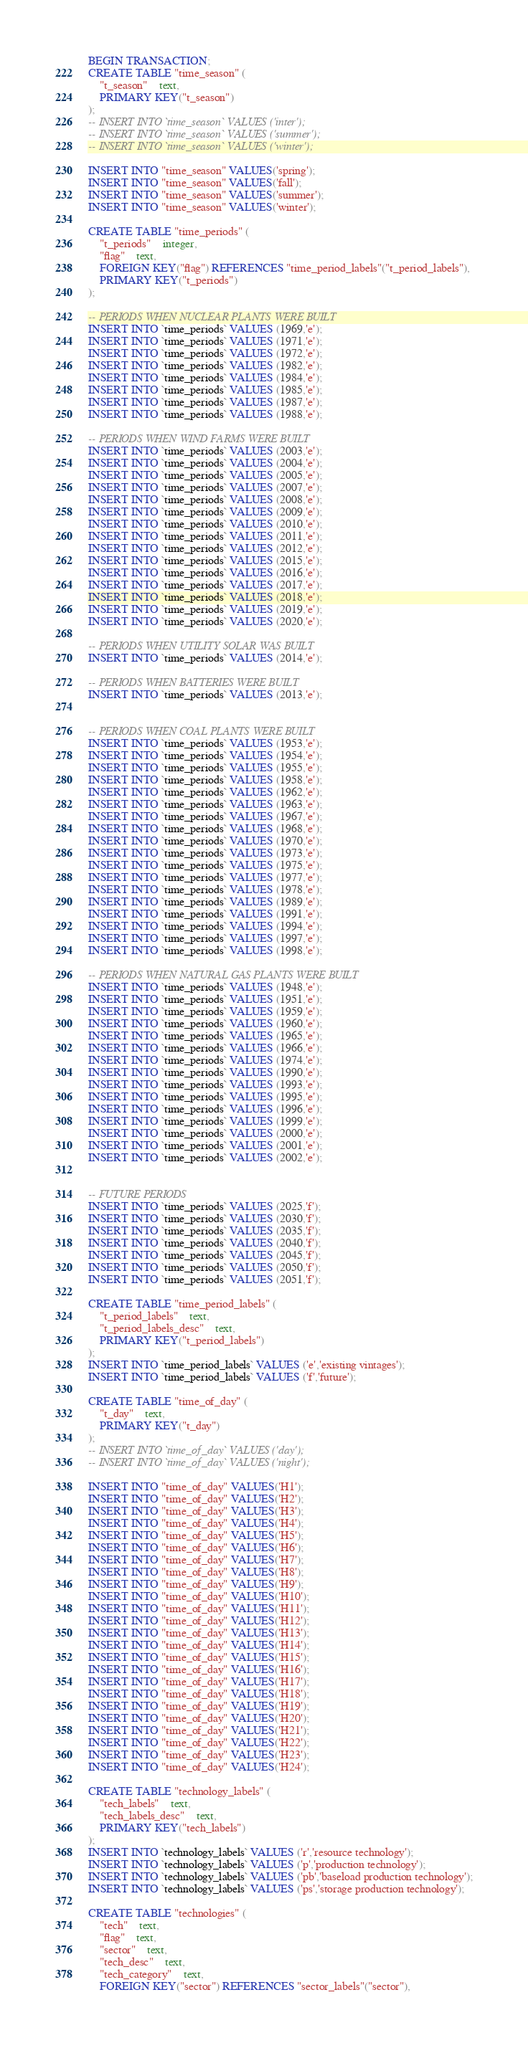Convert code to text. <code><loc_0><loc_0><loc_500><loc_500><_SQL_>BEGIN TRANSACTION;
CREATE TABLE "time_season" (
	"t_season"	text,
	PRIMARY KEY("t_season")
);
-- INSERT INTO `time_season` VALUES ('inter');
-- INSERT INTO `time_season` VALUES ('summer');
-- INSERT INTO `time_season` VALUES ('winter');

INSERT INTO "time_season" VALUES('spring');
INSERT INTO "time_season" VALUES('fall');
INSERT INTO "time_season" VALUES('summer');
INSERT INTO "time_season" VALUES('winter');

CREATE TABLE "time_periods" (
	"t_periods"	integer,
	"flag"	text,
	FOREIGN KEY("flag") REFERENCES "time_period_labels"("t_period_labels"),
	PRIMARY KEY("t_periods")
);

-- PERIODS WHEN NUCLEAR PLANTS WERE BUILT
INSERT INTO `time_periods` VALUES (1969,'e');
INSERT INTO `time_periods` VALUES (1971,'e');
INSERT INTO `time_periods` VALUES (1972,'e');
INSERT INTO `time_periods` VALUES (1982,'e');
INSERT INTO `time_periods` VALUES (1984,'e');
INSERT INTO `time_periods` VALUES (1985,'e');
INSERT INTO `time_periods` VALUES (1987,'e');
INSERT INTO `time_periods` VALUES (1988,'e');

-- PERIODS WHEN WIND FARMS WERE BUILT
INSERT INTO `time_periods` VALUES (2003,'e');
INSERT INTO `time_periods` VALUES (2004,'e');
INSERT INTO `time_periods` VALUES (2005,'e');
INSERT INTO `time_periods` VALUES (2007,'e');
INSERT INTO `time_periods` VALUES (2008,'e');
INSERT INTO `time_periods` VALUES (2009,'e');
INSERT INTO `time_periods` VALUES (2010,'e');
INSERT INTO `time_periods` VALUES (2011,'e');
INSERT INTO `time_periods` VALUES (2012,'e');
INSERT INTO `time_periods` VALUES (2015,'e');
INSERT INTO `time_periods` VALUES (2016,'e');
INSERT INTO `time_periods` VALUES (2017,'e');
INSERT INTO `time_periods` VALUES (2018,'e');
INSERT INTO `time_periods` VALUES (2019,'e');
INSERT INTO `time_periods` VALUES (2020,'e');

-- PERIODS WHEN UTILITY SOLAR WAS BUILT
INSERT INTO `time_periods` VALUES (2014,'e');

-- PERIODS WHEN BATTERIES WERE BUILT
INSERT INTO `time_periods` VALUES (2013,'e');


-- PERIODS WHEN COAL PLANTS WERE BUILT
INSERT INTO `time_periods` VALUES (1953,'e');
INSERT INTO `time_periods` VALUES (1954,'e');
INSERT INTO `time_periods` VALUES (1955,'e');
INSERT INTO `time_periods` VALUES (1958,'e');
INSERT INTO `time_periods` VALUES (1962,'e');
INSERT INTO `time_periods` VALUES (1963,'e');
INSERT INTO `time_periods` VALUES (1967,'e');
INSERT INTO `time_periods` VALUES (1968,'e');
INSERT INTO `time_periods` VALUES (1970,'e');
INSERT INTO `time_periods` VALUES (1973,'e');
INSERT INTO `time_periods` VALUES (1975,'e');
INSERT INTO `time_periods` VALUES (1977,'e');
INSERT INTO `time_periods` VALUES (1978,'e');
INSERT INTO `time_periods` VALUES (1989,'e');
INSERT INTO `time_periods` VALUES (1991,'e');
INSERT INTO `time_periods` VALUES (1994,'e');
INSERT INTO `time_periods` VALUES (1997,'e');
INSERT INTO `time_periods` VALUES (1998,'e');

-- PERIODS WHEN NATURAL GAS PLANTS WERE BUILT
INSERT INTO `time_periods` VALUES (1948,'e');
INSERT INTO `time_periods` VALUES (1951,'e');
INSERT INTO `time_periods` VALUES (1959,'e');
INSERT INTO `time_periods` VALUES (1960,'e');
INSERT INTO `time_periods` VALUES (1965,'e');
INSERT INTO `time_periods` VALUES (1966,'e');
INSERT INTO `time_periods` VALUES (1974,'e');
INSERT INTO `time_periods` VALUES (1990,'e');
INSERT INTO `time_periods` VALUES (1993,'e');
INSERT INTO `time_periods` VALUES (1995,'e');
INSERT INTO `time_periods` VALUES (1996,'e');
INSERT INTO `time_periods` VALUES (1999,'e');
INSERT INTO `time_periods` VALUES (2000,'e');
INSERT INTO `time_periods` VALUES (2001,'e');
INSERT INTO `time_periods` VALUES (2002,'e');


-- FUTURE PERIODS
INSERT INTO `time_periods` VALUES (2025,'f');
INSERT INTO `time_periods` VALUES (2030,'f');
INSERT INTO `time_periods` VALUES (2035,'f');
INSERT INTO `time_periods` VALUES (2040,'f');
INSERT INTO `time_periods` VALUES (2045,'f');
INSERT INTO `time_periods` VALUES (2050,'f');
INSERT INTO `time_periods` VALUES (2051,'f');

CREATE TABLE "time_period_labels" (
	"t_period_labels"	text,
	"t_period_labels_desc"	text,
	PRIMARY KEY("t_period_labels")
);
INSERT INTO `time_period_labels` VALUES ('e','existing vintages');
INSERT INTO `time_period_labels` VALUES ('f','future');

CREATE TABLE "time_of_day" (
	"t_day"	text,
	PRIMARY KEY("t_day")
);
-- INSERT INTO `time_of_day` VALUES ('day');
-- INSERT INTO `time_of_day` VALUES ('night');

INSERT INTO "time_of_day" VALUES('H1');
INSERT INTO "time_of_day" VALUES('H2');
INSERT INTO "time_of_day" VALUES('H3');
INSERT INTO "time_of_day" VALUES('H4');
INSERT INTO "time_of_day" VALUES('H5');
INSERT INTO "time_of_day" VALUES('H6');
INSERT INTO "time_of_day" VALUES('H7');
INSERT INTO "time_of_day" VALUES('H8');
INSERT INTO "time_of_day" VALUES('H9');
INSERT INTO "time_of_day" VALUES('H10');
INSERT INTO "time_of_day" VALUES('H11');
INSERT INTO "time_of_day" VALUES('H12');
INSERT INTO "time_of_day" VALUES('H13');
INSERT INTO "time_of_day" VALUES('H14');
INSERT INTO "time_of_day" VALUES('H15');
INSERT INTO "time_of_day" VALUES('H16');
INSERT INTO "time_of_day" VALUES('H17');
INSERT INTO "time_of_day" VALUES('H18');
INSERT INTO "time_of_day" VALUES('H19');
INSERT INTO "time_of_day" VALUES('H20');
INSERT INTO "time_of_day" VALUES('H21');
INSERT INTO "time_of_day" VALUES('H22');
INSERT INTO "time_of_day" VALUES('H23');
INSERT INTO "time_of_day" VALUES('H24');

CREATE TABLE "technology_labels" (
	"tech_labels"	text,
	"tech_labels_desc"	text,
	PRIMARY KEY("tech_labels")
);
INSERT INTO `technology_labels` VALUES ('r','resource technology');
INSERT INTO `technology_labels` VALUES ('p','production technology');
INSERT INTO `technology_labels` VALUES ('pb','baseload production technology');
INSERT INTO `technology_labels` VALUES ('ps','storage production technology');

CREATE TABLE "technologies" (
	"tech"	text,
	"flag"	text,
	"sector"	text,
	"tech_desc"	text,
	"tech_category"	text,
	FOREIGN KEY("sector") REFERENCES "sector_labels"("sector"),</code> 